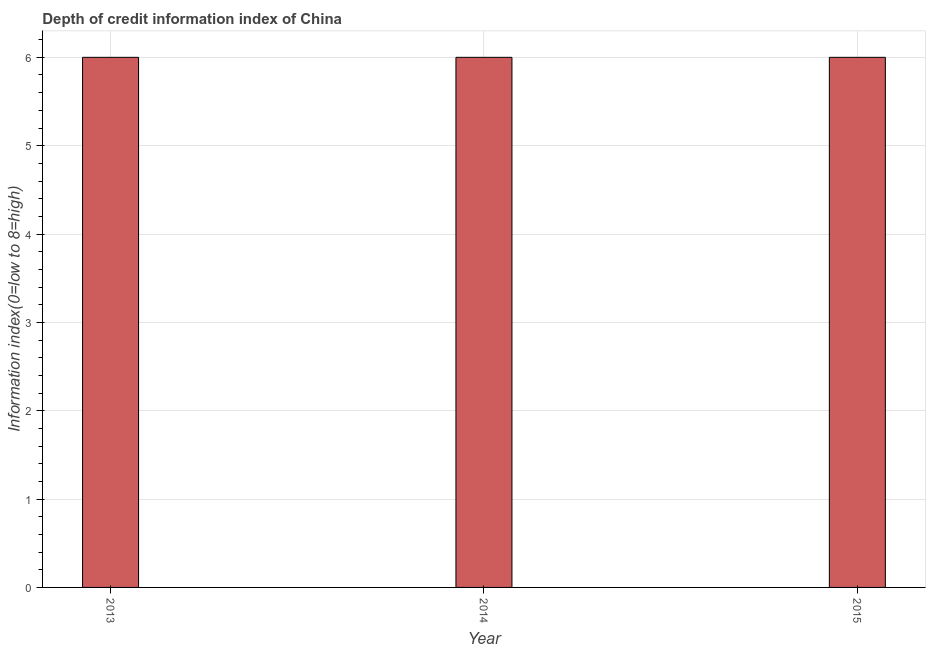What is the title of the graph?
Your response must be concise. Depth of credit information index of China. What is the label or title of the Y-axis?
Offer a terse response. Information index(0=low to 8=high). What is the depth of credit information index in 2014?
Your answer should be very brief. 6. Across all years, what is the maximum depth of credit information index?
Your response must be concise. 6. Across all years, what is the minimum depth of credit information index?
Offer a terse response. 6. In which year was the depth of credit information index minimum?
Provide a succinct answer. 2013. What is the sum of the depth of credit information index?
Provide a short and direct response. 18. In how many years, is the depth of credit information index greater than 2.2 ?
Make the answer very short. 3. What is the ratio of the depth of credit information index in 2013 to that in 2015?
Offer a very short reply. 1. What is the difference between the highest and the lowest depth of credit information index?
Make the answer very short. 0. In how many years, is the depth of credit information index greater than the average depth of credit information index taken over all years?
Provide a succinct answer. 0. How many bars are there?
Ensure brevity in your answer.  3. How many years are there in the graph?
Offer a very short reply. 3. Are the values on the major ticks of Y-axis written in scientific E-notation?
Keep it short and to the point. No. What is the Information index(0=low to 8=high) of 2013?
Provide a short and direct response. 6. What is the Information index(0=low to 8=high) of 2014?
Provide a short and direct response. 6. What is the Information index(0=low to 8=high) in 2015?
Ensure brevity in your answer.  6. What is the ratio of the Information index(0=low to 8=high) in 2014 to that in 2015?
Provide a short and direct response. 1. 